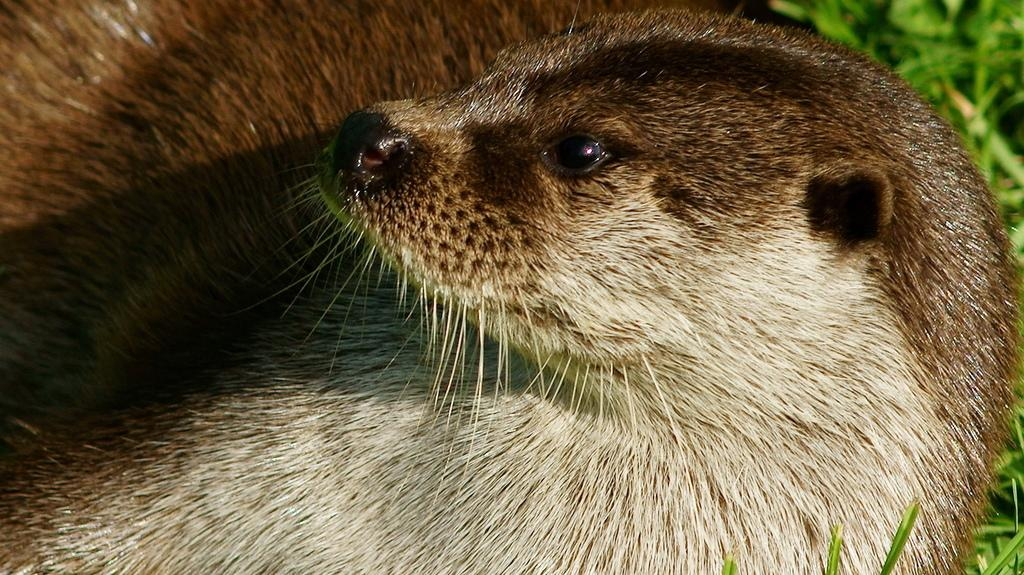What type of living creature is present in the image? There is an animal in the image. What can be seen in the background of the image? There are plants in the background of the image. What type of fuel is the animal using to power its movements in the image? The image does not provide information about the animal's movements or the type of fuel it might be using. 